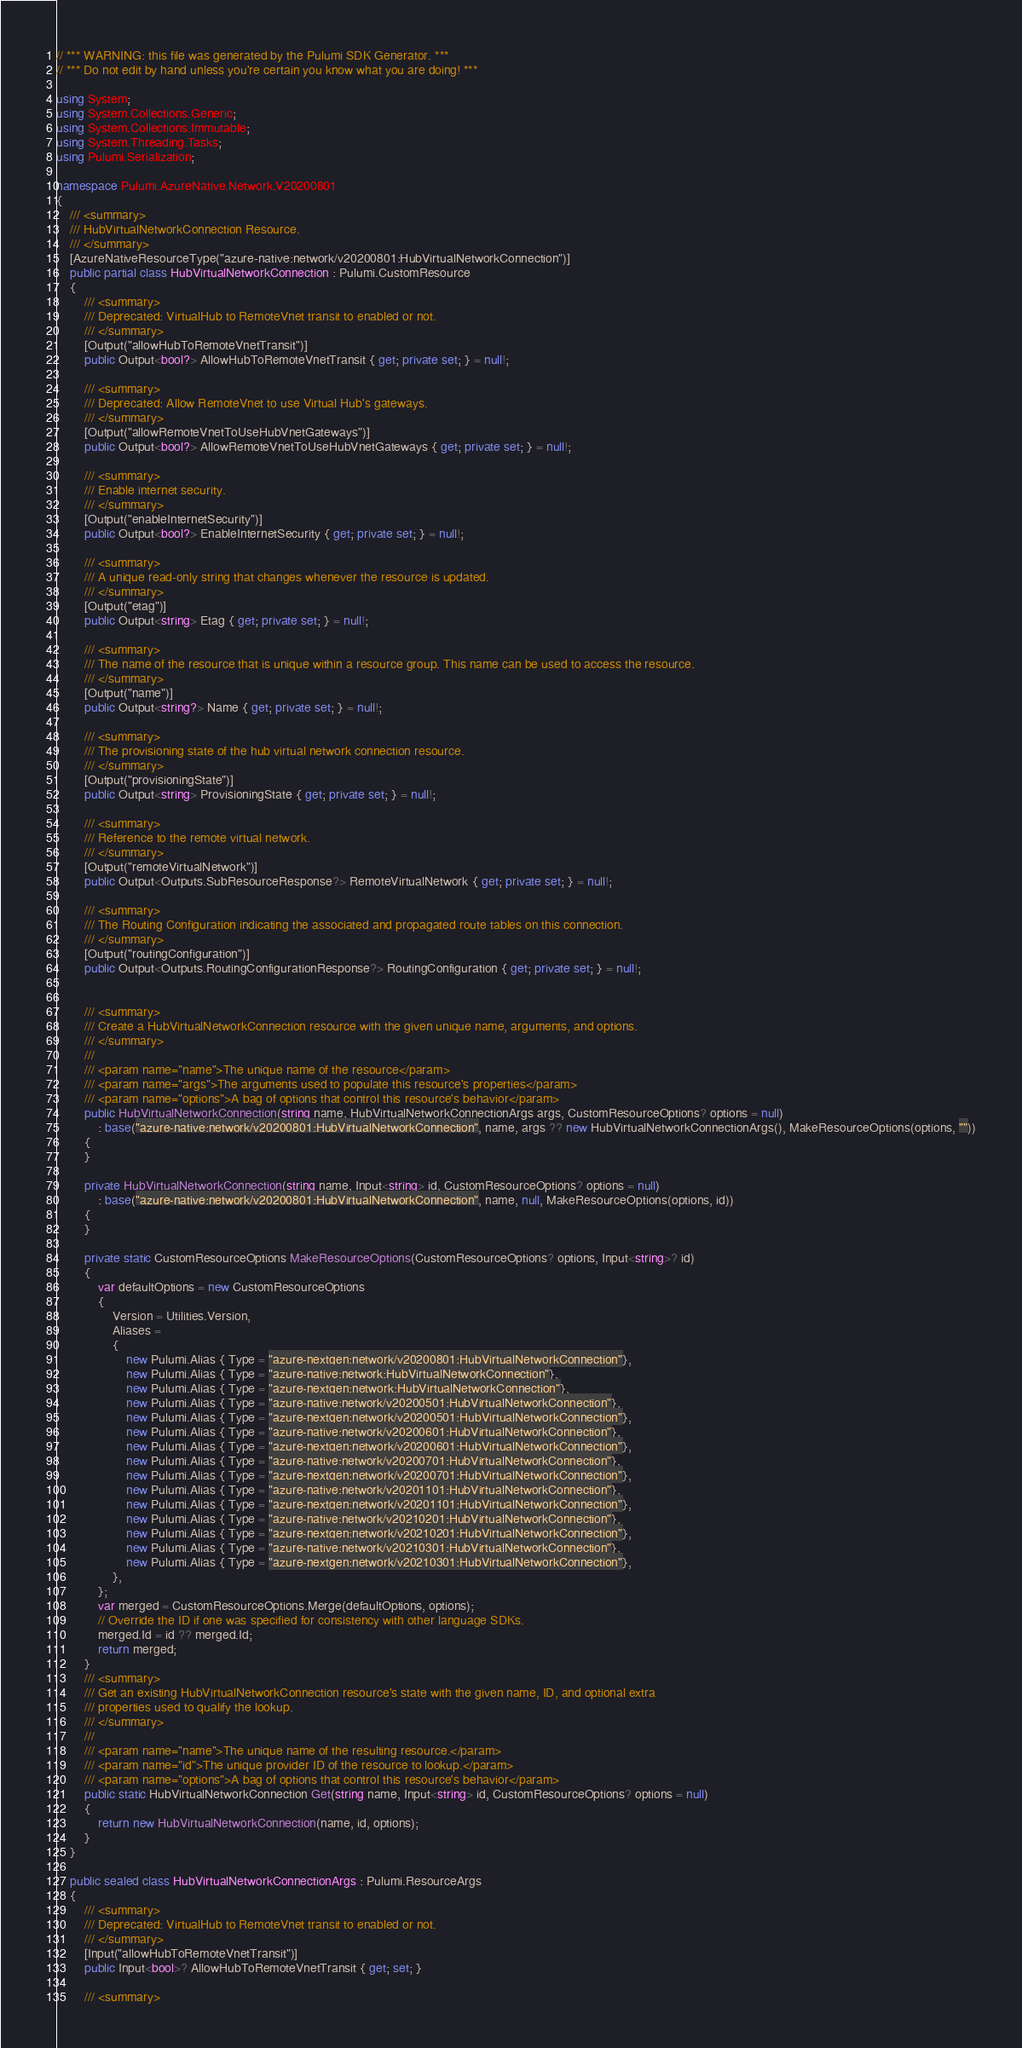<code> <loc_0><loc_0><loc_500><loc_500><_C#_>// *** WARNING: this file was generated by the Pulumi SDK Generator. ***
// *** Do not edit by hand unless you're certain you know what you are doing! ***

using System;
using System.Collections.Generic;
using System.Collections.Immutable;
using System.Threading.Tasks;
using Pulumi.Serialization;

namespace Pulumi.AzureNative.Network.V20200801
{
    /// <summary>
    /// HubVirtualNetworkConnection Resource.
    /// </summary>
    [AzureNativeResourceType("azure-native:network/v20200801:HubVirtualNetworkConnection")]
    public partial class HubVirtualNetworkConnection : Pulumi.CustomResource
    {
        /// <summary>
        /// Deprecated: VirtualHub to RemoteVnet transit to enabled or not.
        /// </summary>
        [Output("allowHubToRemoteVnetTransit")]
        public Output<bool?> AllowHubToRemoteVnetTransit { get; private set; } = null!;

        /// <summary>
        /// Deprecated: Allow RemoteVnet to use Virtual Hub's gateways.
        /// </summary>
        [Output("allowRemoteVnetToUseHubVnetGateways")]
        public Output<bool?> AllowRemoteVnetToUseHubVnetGateways { get; private set; } = null!;

        /// <summary>
        /// Enable internet security.
        /// </summary>
        [Output("enableInternetSecurity")]
        public Output<bool?> EnableInternetSecurity { get; private set; } = null!;

        /// <summary>
        /// A unique read-only string that changes whenever the resource is updated.
        /// </summary>
        [Output("etag")]
        public Output<string> Etag { get; private set; } = null!;

        /// <summary>
        /// The name of the resource that is unique within a resource group. This name can be used to access the resource.
        /// </summary>
        [Output("name")]
        public Output<string?> Name { get; private set; } = null!;

        /// <summary>
        /// The provisioning state of the hub virtual network connection resource.
        /// </summary>
        [Output("provisioningState")]
        public Output<string> ProvisioningState { get; private set; } = null!;

        /// <summary>
        /// Reference to the remote virtual network.
        /// </summary>
        [Output("remoteVirtualNetwork")]
        public Output<Outputs.SubResourceResponse?> RemoteVirtualNetwork { get; private set; } = null!;

        /// <summary>
        /// The Routing Configuration indicating the associated and propagated route tables on this connection.
        /// </summary>
        [Output("routingConfiguration")]
        public Output<Outputs.RoutingConfigurationResponse?> RoutingConfiguration { get; private set; } = null!;


        /// <summary>
        /// Create a HubVirtualNetworkConnection resource with the given unique name, arguments, and options.
        /// </summary>
        ///
        /// <param name="name">The unique name of the resource</param>
        /// <param name="args">The arguments used to populate this resource's properties</param>
        /// <param name="options">A bag of options that control this resource's behavior</param>
        public HubVirtualNetworkConnection(string name, HubVirtualNetworkConnectionArgs args, CustomResourceOptions? options = null)
            : base("azure-native:network/v20200801:HubVirtualNetworkConnection", name, args ?? new HubVirtualNetworkConnectionArgs(), MakeResourceOptions(options, ""))
        {
        }

        private HubVirtualNetworkConnection(string name, Input<string> id, CustomResourceOptions? options = null)
            : base("azure-native:network/v20200801:HubVirtualNetworkConnection", name, null, MakeResourceOptions(options, id))
        {
        }

        private static CustomResourceOptions MakeResourceOptions(CustomResourceOptions? options, Input<string>? id)
        {
            var defaultOptions = new CustomResourceOptions
            {
                Version = Utilities.Version,
                Aliases =
                {
                    new Pulumi.Alias { Type = "azure-nextgen:network/v20200801:HubVirtualNetworkConnection"},
                    new Pulumi.Alias { Type = "azure-native:network:HubVirtualNetworkConnection"},
                    new Pulumi.Alias { Type = "azure-nextgen:network:HubVirtualNetworkConnection"},
                    new Pulumi.Alias { Type = "azure-native:network/v20200501:HubVirtualNetworkConnection"},
                    new Pulumi.Alias { Type = "azure-nextgen:network/v20200501:HubVirtualNetworkConnection"},
                    new Pulumi.Alias { Type = "azure-native:network/v20200601:HubVirtualNetworkConnection"},
                    new Pulumi.Alias { Type = "azure-nextgen:network/v20200601:HubVirtualNetworkConnection"},
                    new Pulumi.Alias { Type = "azure-native:network/v20200701:HubVirtualNetworkConnection"},
                    new Pulumi.Alias { Type = "azure-nextgen:network/v20200701:HubVirtualNetworkConnection"},
                    new Pulumi.Alias { Type = "azure-native:network/v20201101:HubVirtualNetworkConnection"},
                    new Pulumi.Alias { Type = "azure-nextgen:network/v20201101:HubVirtualNetworkConnection"},
                    new Pulumi.Alias { Type = "azure-native:network/v20210201:HubVirtualNetworkConnection"},
                    new Pulumi.Alias { Type = "azure-nextgen:network/v20210201:HubVirtualNetworkConnection"},
                    new Pulumi.Alias { Type = "azure-native:network/v20210301:HubVirtualNetworkConnection"},
                    new Pulumi.Alias { Type = "azure-nextgen:network/v20210301:HubVirtualNetworkConnection"},
                },
            };
            var merged = CustomResourceOptions.Merge(defaultOptions, options);
            // Override the ID if one was specified for consistency with other language SDKs.
            merged.Id = id ?? merged.Id;
            return merged;
        }
        /// <summary>
        /// Get an existing HubVirtualNetworkConnection resource's state with the given name, ID, and optional extra
        /// properties used to qualify the lookup.
        /// </summary>
        ///
        /// <param name="name">The unique name of the resulting resource.</param>
        /// <param name="id">The unique provider ID of the resource to lookup.</param>
        /// <param name="options">A bag of options that control this resource's behavior</param>
        public static HubVirtualNetworkConnection Get(string name, Input<string> id, CustomResourceOptions? options = null)
        {
            return new HubVirtualNetworkConnection(name, id, options);
        }
    }

    public sealed class HubVirtualNetworkConnectionArgs : Pulumi.ResourceArgs
    {
        /// <summary>
        /// Deprecated: VirtualHub to RemoteVnet transit to enabled or not.
        /// </summary>
        [Input("allowHubToRemoteVnetTransit")]
        public Input<bool>? AllowHubToRemoteVnetTransit { get; set; }

        /// <summary></code> 